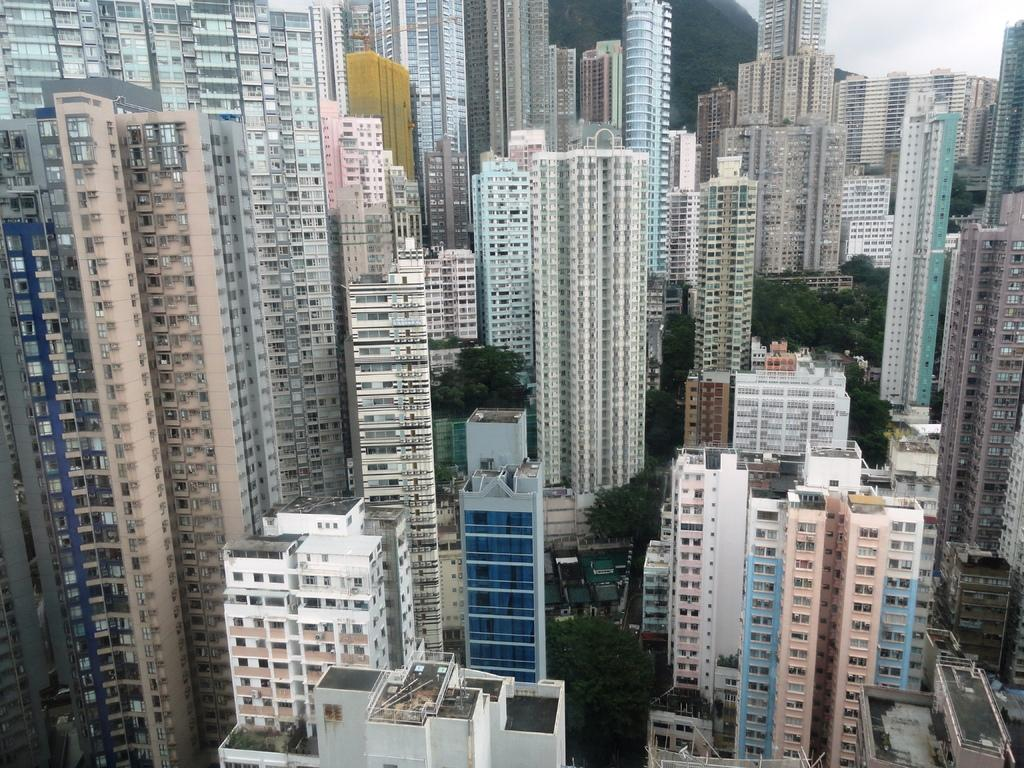What type of structures can be seen in the image? There are buildings in the image. What other natural elements are present in the image? There are trees in the image. How would you describe the weather based on the image? The sky is cloudy in the image, suggesting a potentially overcast or cloudy day. What type of bird can be seen perched on the copper can in the image? There is no bird, copper can, or any other object mentioned in the provided facts. 